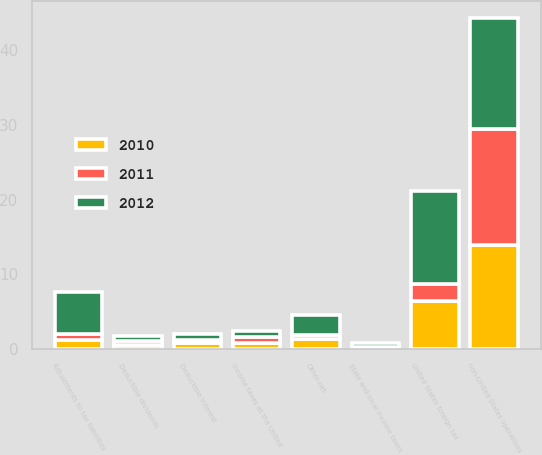<chart> <loc_0><loc_0><loc_500><loc_500><stacked_bar_chart><ecel><fcel>Income taxes at the United<fcel>State and local income taxes<fcel>Deductible dividends<fcel>Deductible interest<fcel>Other-net<fcel>United States foreign tax<fcel>non-United States operations<fcel>Adjustments to tax liabilities<nl><fcel>2012<fcel>0.8<fcel>0.6<fcel>0.7<fcel>0.8<fcel>2.7<fcel>12.4<fcel>14.9<fcel>5.7<nl><fcel>2011<fcel>0.8<fcel>0.2<fcel>0.5<fcel>0.5<fcel>0.5<fcel>2.3<fcel>15.5<fcel>0.8<nl><fcel>2010<fcel>0.8<fcel>0.1<fcel>0.6<fcel>0.8<fcel>1.4<fcel>6.4<fcel>13.9<fcel>1.2<nl></chart> 